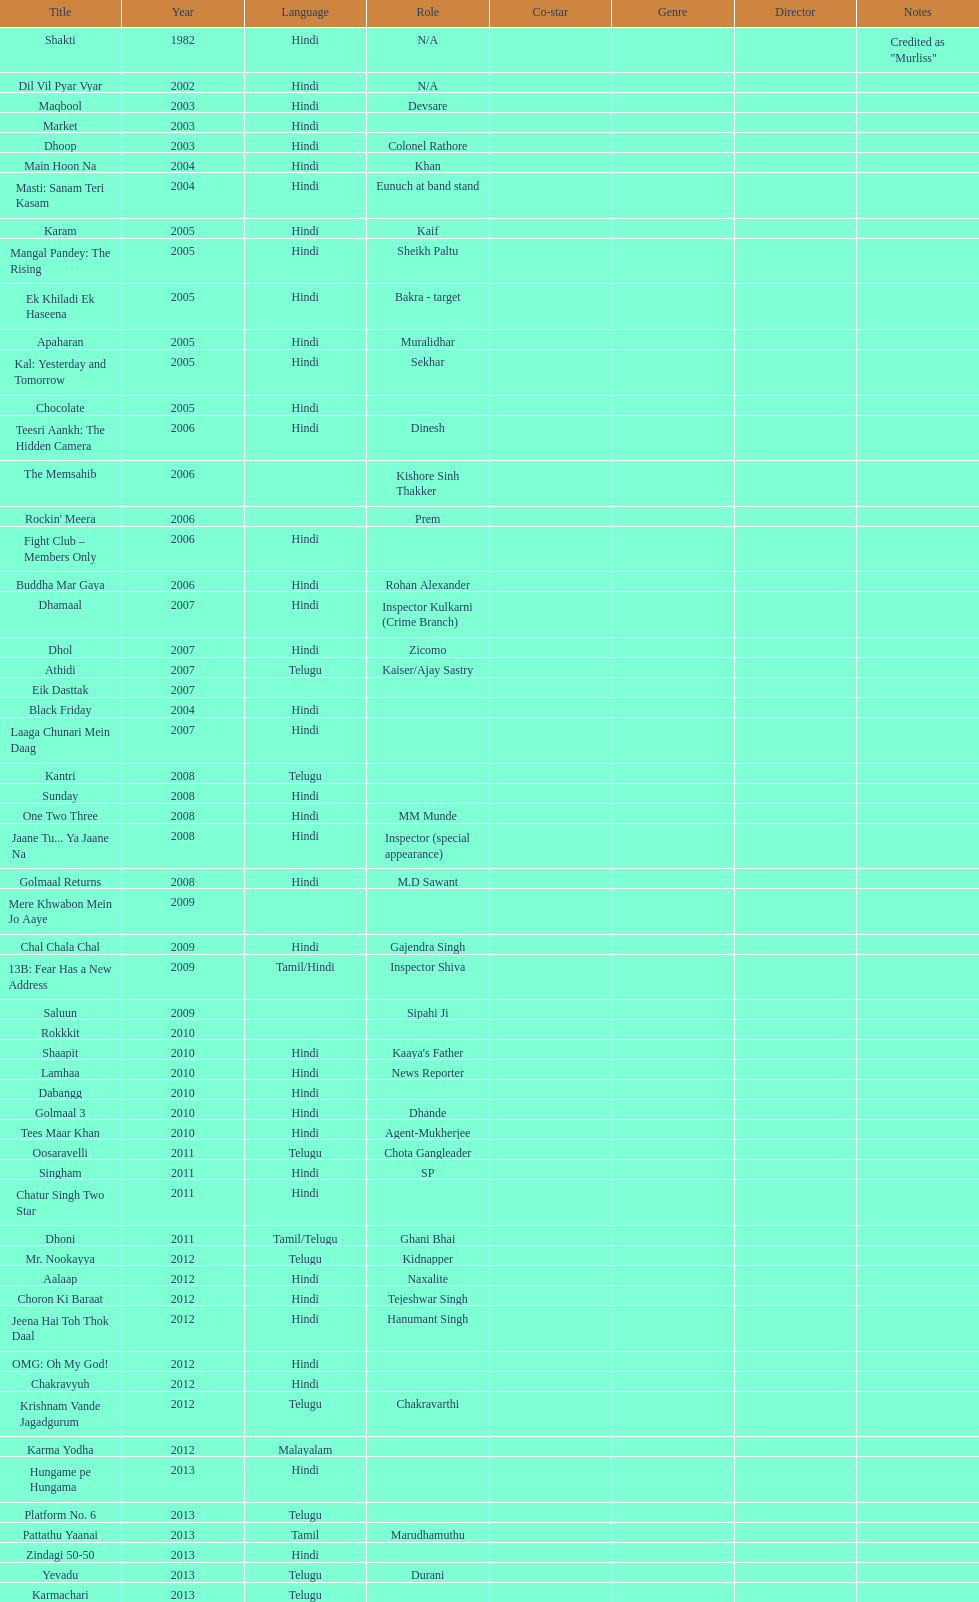What was the last malayalam film this actor starred in? Karma Yodha. 